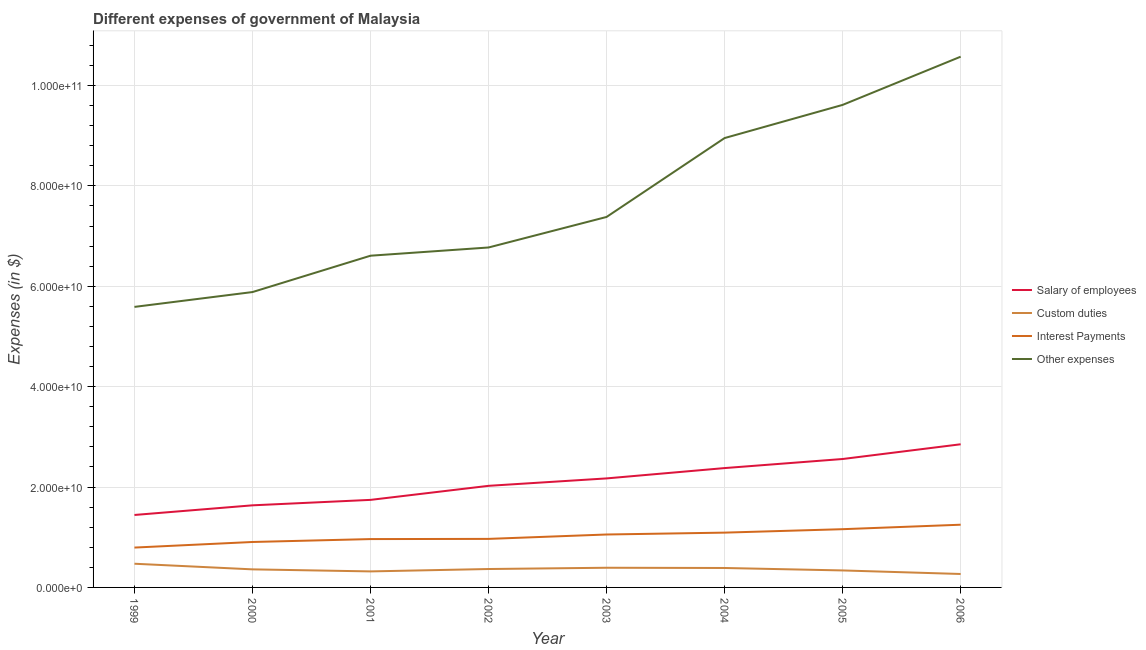How many different coloured lines are there?
Provide a succinct answer. 4. Does the line corresponding to amount spent on interest payments intersect with the line corresponding to amount spent on other expenses?
Provide a succinct answer. No. Is the number of lines equal to the number of legend labels?
Your response must be concise. Yes. What is the amount spent on salary of employees in 2003?
Give a very brief answer. 2.17e+1. Across all years, what is the maximum amount spent on custom duties?
Ensure brevity in your answer.  4.72e+09. Across all years, what is the minimum amount spent on interest payments?
Keep it short and to the point. 7.94e+09. In which year was the amount spent on salary of employees maximum?
Offer a terse response. 2006. In which year was the amount spent on other expenses minimum?
Ensure brevity in your answer.  1999. What is the total amount spent on custom duties in the graph?
Your answer should be compact. 2.90e+1. What is the difference between the amount spent on interest payments in 2001 and that in 2005?
Make the answer very short. -1.97e+09. What is the difference between the amount spent on other expenses in 2000 and the amount spent on custom duties in 2006?
Offer a terse response. 5.62e+1. What is the average amount spent on interest payments per year?
Ensure brevity in your answer.  1.02e+1. In the year 2005, what is the difference between the amount spent on other expenses and amount spent on custom duties?
Make the answer very short. 9.28e+1. What is the ratio of the amount spent on salary of employees in 2005 to that in 2006?
Give a very brief answer. 0.9. Is the amount spent on interest payments in 1999 less than that in 2006?
Offer a very short reply. Yes. What is the difference between the highest and the second highest amount spent on custom duties?
Provide a short and direct response. 8.01e+08. What is the difference between the highest and the lowest amount spent on custom duties?
Make the answer very short. 2.04e+09. Is it the case that in every year, the sum of the amount spent on other expenses and amount spent on interest payments is greater than the sum of amount spent on custom duties and amount spent on salary of employees?
Make the answer very short. No. Does the amount spent on salary of employees monotonically increase over the years?
Your response must be concise. Yes. Is the amount spent on custom duties strictly greater than the amount spent on other expenses over the years?
Give a very brief answer. No. Is the amount spent on interest payments strictly less than the amount spent on salary of employees over the years?
Make the answer very short. Yes. How many lines are there?
Your response must be concise. 4. How many years are there in the graph?
Ensure brevity in your answer.  8. What is the difference between two consecutive major ticks on the Y-axis?
Ensure brevity in your answer.  2.00e+1. Are the values on the major ticks of Y-axis written in scientific E-notation?
Ensure brevity in your answer.  Yes. Does the graph contain any zero values?
Make the answer very short. No. Where does the legend appear in the graph?
Your response must be concise. Center right. What is the title of the graph?
Your answer should be very brief. Different expenses of government of Malaysia. What is the label or title of the Y-axis?
Provide a succinct answer. Expenses (in $). What is the Expenses (in $) in Salary of employees in 1999?
Provide a short and direct response. 1.44e+1. What is the Expenses (in $) in Custom duties in 1999?
Give a very brief answer. 4.72e+09. What is the Expenses (in $) of Interest Payments in 1999?
Provide a short and direct response. 7.94e+09. What is the Expenses (in $) of Other expenses in 1999?
Your answer should be compact. 5.59e+1. What is the Expenses (in $) of Salary of employees in 2000?
Keep it short and to the point. 1.64e+1. What is the Expenses (in $) of Custom duties in 2000?
Your answer should be very brief. 3.60e+09. What is the Expenses (in $) of Interest Payments in 2000?
Give a very brief answer. 9.06e+09. What is the Expenses (in $) of Other expenses in 2000?
Provide a short and direct response. 5.88e+1. What is the Expenses (in $) in Salary of employees in 2001?
Give a very brief answer. 1.74e+1. What is the Expenses (in $) in Custom duties in 2001?
Your answer should be compact. 3.19e+09. What is the Expenses (in $) in Interest Payments in 2001?
Keep it short and to the point. 9.63e+09. What is the Expenses (in $) of Other expenses in 2001?
Your answer should be very brief. 6.61e+1. What is the Expenses (in $) of Salary of employees in 2002?
Your answer should be compact. 2.02e+1. What is the Expenses (in $) in Custom duties in 2002?
Give a very brief answer. 3.67e+09. What is the Expenses (in $) of Interest Payments in 2002?
Provide a short and direct response. 9.67e+09. What is the Expenses (in $) of Other expenses in 2002?
Your answer should be very brief. 6.77e+1. What is the Expenses (in $) of Salary of employees in 2003?
Ensure brevity in your answer.  2.17e+1. What is the Expenses (in $) of Custom duties in 2003?
Make the answer very short. 3.92e+09. What is the Expenses (in $) in Interest Payments in 2003?
Offer a terse response. 1.05e+1. What is the Expenses (in $) in Other expenses in 2003?
Ensure brevity in your answer.  7.38e+1. What is the Expenses (in $) in Salary of employees in 2004?
Offer a terse response. 2.38e+1. What is the Expenses (in $) of Custom duties in 2004?
Provide a succinct answer. 3.87e+09. What is the Expenses (in $) of Interest Payments in 2004?
Make the answer very short. 1.09e+1. What is the Expenses (in $) of Other expenses in 2004?
Keep it short and to the point. 8.95e+1. What is the Expenses (in $) of Salary of employees in 2005?
Your response must be concise. 2.56e+1. What is the Expenses (in $) in Custom duties in 2005?
Offer a very short reply. 3.38e+09. What is the Expenses (in $) in Interest Payments in 2005?
Offer a very short reply. 1.16e+1. What is the Expenses (in $) of Other expenses in 2005?
Offer a very short reply. 9.61e+1. What is the Expenses (in $) of Salary of employees in 2006?
Your answer should be compact. 2.85e+1. What is the Expenses (in $) of Custom duties in 2006?
Offer a very short reply. 2.68e+09. What is the Expenses (in $) in Interest Payments in 2006?
Offer a very short reply. 1.25e+1. What is the Expenses (in $) of Other expenses in 2006?
Provide a short and direct response. 1.06e+11. Across all years, what is the maximum Expenses (in $) in Salary of employees?
Your answer should be very brief. 2.85e+1. Across all years, what is the maximum Expenses (in $) of Custom duties?
Make the answer very short. 4.72e+09. Across all years, what is the maximum Expenses (in $) of Interest Payments?
Ensure brevity in your answer.  1.25e+1. Across all years, what is the maximum Expenses (in $) of Other expenses?
Provide a succinct answer. 1.06e+11. Across all years, what is the minimum Expenses (in $) of Salary of employees?
Make the answer very short. 1.44e+1. Across all years, what is the minimum Expenses (in $) in Custom duties?
Ensure brevity in your answer.  2.68e+09. Across all years, what is the minimum Expenses (in $) of Interest Payments?
Your answer should be very brief. 7.94e+09. Across all years, what is the minimum Expenses (in $) in Other expenses?
Your response must be concise. 5.59e+1. What is the total Expenses (in $) of Salary of employees in the graph?
Give a very brief answer. 1.68e+11. What is the total Expenses (in $) of Custom duties in the graph?
Ensure brevity in your answer.  2.90e+1. What is the total Expenses (in $) in Interest Payments in the graph?
Your answer should be very brief. 8.19e+1. What is the total Expenses (in $) in Other expenses in the graph?
Give a very brief answer. 6.14e+11. What is the difference between the Expenses (in $) in Salary of employees in 1999 and that in 2000?
Ensure brevity in your answer.  -1.92e+09. What is the difference between the Expenses (in $) of Custom duties in 1999 and that in 2000?
Make the answer very short. 1.12e+09. What is the difference between the Expenses (in $) of Interest Payments in 1999 and that in 2000?
Your response must be concise. -1.11e+09. What is the difference between the Expenses (in $) in Other expenses in 1999 and that in 2000?
Your answer should be very brief. -2.96e+09. What is the difference between the Expenses (in $) in Salary of employees in 1999 and that in 2001?
Your answer should be very brief. -3.01e+09. What is the difference between the Expenses (in $) in Custom duties in 1999 and that in 2001?
Your response must be concise. 1.53e+09. What is the difference between the Expenses (in $) of Interest Payments in 1999 and that in 2001?
Give a very brief answer. -1.69e+09. What is the difference between the Expenses (in $) of Other expenses in 1999 and that in 2001?
Give a very brief answer. -1.02e+1. What is the difference between the Expenses (in $) of Salary of employees in 1999 and that in 2002?
Offer a very short reply. -5.81e+09. What is the difference between the Expenses (in $) of Custom duties in 1999 and that in 2002?
Provide a succinct answer. 1.05e+09. What is the difference between the Expenses (in $) of Interest Payments in 1999 and that in 2002?
Offer a terse response. -1.73e+09. What is the difference between the Expenses (in $) in Other expenses in 1999 and that in 2002?
Make the answer very short. -1.18e+1. What is the difference between the Expenses (in $) in Salary of employees in 1999 and that in 2003?
Ensure brevity in your answer.  -7.28e+09. What is the difference between the Expenses (in $) in Custom duties in 1999 and that in 2003?
Offer a very short reply. 8.01e+08. What is the difference between the Expenses (in $) in Interest Payments in 1999 and that in 2003?
Your answer should be very brief. -2.60e+09. What is the difference between the Expenses (in $) of Other expenses in 1999 and that in 2003?
Your response must be concise. -1.79e+1. What is the difference between the Expenses (in $) of Salary of employees in 1999 and that in 2004?
Keep it short and to the point. -9.34e+09. What is the difference between the Expenses (in $) in Custom duties in 1999 and that in 2004?
Ensure brevity in your answer.  8.46e+08. What is the difference between the Expenses (in $) of Interest Payments in 1999 and that in 2004?
Offer a terse response. -2.98e+09. What is the difference between the Expenses (in $) in Other expenses in 1999 and that in 2004?
Your answer should be very brief. -3.36e+1. What is the difference between the Expenses (in $) in Salary of employees in 1999 and that in 2005?
Your response must be concise. -1.12e+1. What is the difference between the Expenses (in $) of Custom duties in 1999 and that in 2005?
Provide a short and direct response. 1.34e+09. What is the difference between the Expenses (in $) in Interest Payments in 1999 and that in 2005?
Make the answer very short. -3.66e+09. What is the difference between the Expenses (in $) in Other expenses in 1999 and that in 2005?
Provide a short and direct response. -4.02e+1. What is the difference between the Expenses (in $) in Salary of employees in 1999 and that in 2006?
Your answer should be very brief. -1.41e+1. What is the difference between the Expenses (in $) of Custom duties in 1999 and that in 2006?
Your answer should be compact. 2.04e+09. What is the difference between the Expenses (in $) in Interest Payments in 1999 and that in 2006?
Your answer should be compact. -4.55e+09. What is the difference between the Expenses (in $) of Other expenses in 1999 and that in 2006?
Offer a terse response. -4.99e+1. What is the difference between the Expenses (in $) in Salary of employees in 2000 and that in 2001?
Offer a terse response. -1.09e+09. What is the difference between the Expenses (in $) of Custom duties in 2000 and that in 2001?
Your answer should be very brief. 4.06e+08. What is the difference between the Expenses (in $) of Interest Payments in 2000 and that in 2001?
Your response must be concise. -5.79e+08. What is the difference between the Expenses (in $) in Other expenses in 2000 and that in 2001?
Provide a succinct answer. -7.24e+09. What is the difference between the Expenses (in $) of Salary of employees in 2000 and that in 2002?
Give a very brief answer. -3.88e+09. What is the difference between the Expenses (in $) of Custom duties in 2000 and that in 2002?
Offer a terse response. -6.89e+07. What is the difference between the Expenses (in $) in Interest Payments in 2000 and that in 2002?
Provide a succinct answer. -6.14e+08. What is the difference between the Expenses (in $) of Other expenses in 2000 and that in 2002?
Your answer should be very brief. -8.88e+09. What is the difference between the Expenses (in $) in Salary of employees in 2000 and that in 2003?
Offer a terse response. -5.36e+09. What is the difference between the Expenses (in $) of Custom duties in 2000 and that in 2003?
Make the answer very short. -3.20e+08. What is the difference between the Expenses (in $) in Interest Payments in 2000 and that in 2003?
Provide a succinct answer. -1.49e+09. What is the difference between the Expenses (in $) of Other expenses in 2000 and that in 2003?
Your response must be concise. -1.50e+1. What is the difference between the Expenses (in $) in Salary of employees in 2000 and that in 2004?
Give a very brief answer. -7.42e+09. What is the difference between the Expenses (in $) of Custom duties in 2000 and that in 2004?
Your answer should be very brief. -2.75e+08. What is the difference between the Expenses (in $) of Interest Payments in 2000 and that in 2004?
Provide a short and direct response. -1.86e+09. What is the difference between the Expenses (in $) of Other expenses in 2000 and that in 2004?
Keep it short and to the point. -3.07e+1. What is the difference between the Expenses (in $) of Salary of employees in 2000 and that in 2005?
Ensure brevity in your answer.  -9.23e+09. What is the difference between the Expenses (in $) in Custom duties in 2000 and that in 2005?
Provide a succinct answer. 2.14e+08. What is the difference between the Expenses (in $) in Interest Payments in 2000 and that in 2005?
Offer a very short reply. -2.55e+09. What is the difference between the Expenses (in $) in Other expenses in 2000 and that in 2005?
Your answer should be very brief. -3.73e+1. What is the difference between the Expenses (in $) in Salary of employees in 2000 and that in 2006?
Make the answer very short. -1.22e+1. What is the difference between the Expenses (in $) in Custom duties in 2000 and that in 2006?
Your answer should be compact. 9.20e+08. What is the difference between the Expenses (in $) in Interest Payments in 2000 and that in 2006?
Provide a short and direct response. -3.44e+09. What is the difference between the Expenses (in $) of Other expenses in 2000 and that in 2006?
Provide a succinct answer. -4.69e+1. What is the difference between the Expenses (in $) of Salary of employees in 2001 and that in 2002?
Keep it short and to the point. -2.80e+09. What is the difference between the Expenses (in $) of Custom duties in 2001 and that in 2002?
Your response must be concise. -4.75e+08. What is the difference between the Expenses (in $) in Interest Payments in 2001 and that in 2002?
Offer a very short reply. -3.50e+07. What is the difference between the Expenses (in $) of Other expenses in 2001 and that in 2002?
Keep it short and to the point. -1.64e+09. What is the difference between the Expenses (in $) in Salary of employees in 2001 and that in 2003?
Your answer should be very brief. -4.28e+09. What is the difference between the Expenses (in $) in Custom duties in 2001 and that in 2003?
Your answer should be compact. -7.26e+08. What is the difference between the Expenses (in $) of Interest Payments in 2001 and that in 2003?
Ensure brevity in your answer.  -9.12e+08. What is the difference between the Expenses (in $) in Other expenses in 2001 and that in 2003?
Offer a very short reply. -7.72e+09. What is the difference between the Expenses (in $) in Salary of employees in 2001 and that in 2004?
Keep it short and to the point. -6.34e+09. What is the difference between the Expenses (in $) in Custom duties in 2001 and that in 2004?
Keep it short and to the point. -6.81e+08. What is the difference between the Expenses (in $) of Interest Payments in 2001 and that in 2004?
Provide a short and direct response. -1.28e+09. What is the difference between the Expenses (in $) of Other expenses in 2001 and that in 2004?
Make the answer very short. -2.34e+1. What is the difference between the Expenses (in $) in Salary of employees in 2001 and that in 2005?
Keep it short and to the point. -8.14e+09. What is the difference between the Expenses (in $) in Custom duties in 2001 and that in 2005?
Keep it short and to the point. -1.92e+08. What is the difference between the Expenses (in $) in Interest Payments in 2001 and that in 2005?
Keep it short and to the point. -1.97e+09. What is the difference between the Expenses (in $) in Other expenses in 2001 and that in 2005?
Your answer should be compact. -3.00e+1. What is the difference between the Expenses (in $) of Salary of employees in 2001 and that in 2006?
Offer a very short reply. -1.11e+1. What is the difference between the Expenses (in $) of Custom duties in 2001 and that in 2006?
Give a very brief answer. 5.14e+08. What is the difference between the Expenses (in $) in Interest Payments in 2001 and that in 2006?
Provide a succinct answer. -2.86e+09. What is the difference between the Expenses (in $) in Other expenses in 2001 and that in 2006?
Your answer should be very brief. -3.97e+1. What is the difference between the Expenses (in $) of Salary of employees in 2002 and that in 2003?
Your answer should be very brief. -1.48e+09. What is the difference between the Expenses (in $) of Custom duties in 2002 and that in 2003?
Your answer should be very brief. -2.51e+08. What is the difference between the Expenses (in $) in Interest Payments in 2002 and that in 2003?
Provide a succinct answer. -8.77e+08. What is the difference between the Expenses (in $) of Other expenses in 2002 and that in 2003?
Provide a short and direct response. -6.08e+09. What is the difference between the Expenses (in $) in Salary of employees in 2002 and that in 2004?
Your answer should be very brief. -3.54e+09. What is the difference between the Expenses (in $) in Custom duties in 2002 and that in 2004?
Your answer should be very brief. -2.06e+08. What is the difference between the Expenses (in $) in Interest Payments in 2002 and that in 2004?
Keep it short and to the point. -1.25e+09. What is the difference between the Expenses (in $) in Other expenses in 2002 and that in 2004?
Ensure brevity in your answer.  -2.18e+1. What is the difference between the Expenses (in $) in Salary of employees in 2002 and that in 2005?
Make the answer very short. -5.34e+09. What is the difference between the Expenses (in $) in Custom duties in 2002 and that in 2005?
Provide a short and direct response. 2.83e+08. What is the difference between the Expenses (in $) of Interest Payments in 2002 and that in 2005?
Keep it short and to the point. -1.94e+09. What is the difference between the Expenses (in $) in Other expenses in 2002 and that in 2005?
Ensure brevity in your answer.  -2.84e+1. What is the difference between the Expenses (in $) in Salary of employees in 2002 and that in 2006?
Provide a succinct answer. -8.28e+09. What is the difference between the Expenses (in $) of Custom duties in 2002 and that in 2006?
Provide a short and direct response. 9.89e+08. What is the difference between the Expenses (in $) in Interest Payments in 2002 and that in 2006?
Provide a short and direct response. -2.83e+09. What is the difference between the Expenses (in $) of Other expenses in 2002 and that in 2006?
Your answer should be very brief. -3.80e+1. What is the difference between the Expenses (in $) in Salary of employees in 2003 and that in 2004?
Provide a short and direct response. -2.06e+09. What is the difference between the Expenses (in $) in Custom duties in 2003 and that in 2004?
Provide a short and direct response. 4.50e+07. What is the difference between the Expenses (in $) in Interest Payments in 2003 and that in 2004?
Ensure brevity in your answer.  -3.73e+08. What is the difference between the Expenses (in $) of Other expenses in 2003 and that in 2004?
Your answer should be compact. -1.57e+1. What is the difference between the Expenses (in $) in Salary of employees in 2003 and that in 2005?
Ensure brevity in your answer.  -3.87e+09. What is the difference between the Expenses (in $) of Custom duties in 2003 and that in 2005?
Provide a succinct answer. 5.34e+08. What is the difference between the Expenses (in $) in Interest Payments in 2003 and that in 2005?
Your response must be concise. -1.06e+09. What is the difference between the Expenses (in $) in Other expenses in 2003 and that in 2005?
Offer a terse response. -2.23e+1. What is the difference between the Expenses (in $) in Salary of employees in 2003 and that in 2006?
Offer a terse response. -6.80e+09. What is the difference between the Expenses (in $) of Custom duties in 2003 and that in 2006?
Provide a succinct answer. 1.24e+09. What is the difference between the Expenses (in $) in Interest Payments in 2003 and that in 2006?
Ensure brevity in your answer.  -1.95e+09. What is the difference between the Expenses (in $) in Other expenses in 2003 and that in 2006?
Give a very brief answer. -3.19e+1. What is the difference between the Expenses (in $) of Salary of employees in 2004 and that in 2005?
Your answer should be very brief. -1.81e+09. What is the difference between the Expenses (in $) in Custom duties in 2004 and that in 2005?
Your answer should be very brief. 4.89e+08. What is the difference between the Expenses (in $) of Interest Payments in 2004 and that in 2005?
Offer a terse response. -6.85e+08. What is the difference between the Expenses (in $) in Other expenses in 2004 and that in 2005?
Offer a very short reply. -6.61e+09. What is the difference between the Expenses (in $) of Salary of employees in 2004 and that in 2006?
Offer a very short reply. -4.74e+09. What is the difference between the Expenses (in $) in Custom duties in 2004 and that in 2006?
Offer a terse response. 1.20e+09. What is the difference between the Expenses (in $) of Interest Payments in 2004 and that in 2006?
Give a very brief answer. -1.58e+09. What is the difference between the Expenses (in $) of Other expenses in 2004 and that in 2006?
Offer a terse response. -1.62e+1. What is the difference between the Expenses (in $) of Salary of employees in 2005 and that in 2006?
Keep it short and to the point. -2.93e+09. What is the difference between the Expenses (in $) in Custom duties in 2005 and that in 2006?
Give a very brief answer. 7.06e+08. What is the difference between the Expenses (in $) in Interest Payments in 2005 and that in 2006?
Your answer should be compact. -8.91e+08. What is the difference between the Expenses (in $) in Other expenses in 2005 and that in 2006?
Your answer should be very brief. -9.60e+09. What is the difference between the Expenses (in $) in Salary of employees in 1999 and the Expenses (in $) in Custom duties in 2000?
Ensure brevity in your answer.  1.08e+1. What is the difference between the Expenses (in $) in Salary of employees in 1999 and the Expenses (in $) in Interest Payments in 2000?
Make the answer very short. 5.38e+09. What is the difference between the Expenses (in $) in Salary of employees in 1999 and the Expenses (in $) in Other expenses in 2000?
Ensure brevity in your answer.  -4.44e+1. What is the difference between the Expenses (in $) in Custom duties in 1999 and the Expenses (in $) in Interest Payments in 2000?
Offer a terse response. -4.33e+09. What is the difference between the Expenses (in $) in Custom duties in 1999 and the Expenses (in $) in Other expenses in 2000?
Offer a very short reply. -5.41e+1. What is the difference between the Expenses (in $) of Interest Payments in 1999 and the Expenses (in $) of Other expenses in 2000?
Offer a terse response. -5.09e+1. What is the difference between the Expenses (in $) of Salary of employees in 1999 and the Expenses (in $) of Custom duties in 2001?
Give a very brief answer. 1.12e+1. What is the difference between the Expenses (in $) of Salary of employees in 1999 and the Expenses (in $) of Interest Payments in 2001?
Make the answer very short. 4.80e+09. What is the difference between the Expenses (in $) in Salary of employees in 1999 and the Expenses (in $) in Other expenses in 2001?
Ensure brevity in your answer.  -5.17e+1. What is the difference between the Expenses (in $) in Custom duties in 1999 and the Expenses (in $) in Interest Payments in 2001?
Give a very brief answer. -4.91e+09. What is the difference between the Expenses (in $) of Custom duties in 1999 and the Expenses (in $) of Other expenses in 2001?
Make the answer very short. -6.14e+1. What is the difference between the Expenses (in $) of Interest Payments in 1999 and the Expenses (in $) of Other expenses in 2001?
Provide a short and direct response. -5.82e+1. What is the difference between the Expenses (in $) in Salary of employees in 1999 and the Expenses (in $) in Custom duties in 2002?
Make the answer very short. 1.08e+1. What is the difference between the Expenses (in $) of Salary of employees in 1999 and the Expenses (in $) of Interest Payments in 2002?
Provide a succinct answer. 4.77e+09. What is the difference between the Expenses (in $) in Salary of employees in 1999 and the Expenses (in $) in Other expenses in 2002?
Offer a terse response. -5.33e+1. What is the difference between the Expenses (in $) of Custom duties in 1999 and the Expenses (in $) of Interest Payments in 2002?
Offer a very short reply. -4.95e+09. What is the difference between the Expenses (in $) in Custom duties in 1999 and the Expenses (in $) in Other expenses in 2002?
Ensure brevity in your answer.  -6.30e+1. What is the difference between the Expenses (in $) in Interest Payments in 1999 and the Expenses (in $) in Other expenses in 2002?
Ensure brevity in your answer.  -5.98e+1. What is the difference between the Expenses (in $) of Salary of employees in 1999 and the Expenses (in $) of Custom duties in 2003?
Your answer should be very brief. 1.05e+1. What is the difference between the Expenses (in $) of Salary of employees in 1999 and the Expenses (in $) of Interest Payments in 2003?
Provide a short and direct response. 3.89e+09. What is the difference between the Expenses (in $) of Salary of employees in 1999 and the Expenses (in $) of Other expenses in 2003?
Offer a very short reply. -5.94e+1. What is the difference between the Expenses (in $) of Custom duties in 1999 and the Expenses (in $) of Interest Payments in 2003?
Make the answer very short. -5.83e+09. What is the difference between the Expenses (in $) in Custom duties in 1999 and the Expenses (in $) in Other expenses in 2003?
Give a very brief answer. -6.91e+1. What is the difference between the Expenses (in $) of Interest Payments in 1999 and the Expenses (in $) of Other expenses in 2003?
Keep it short and to the point. -6.59e+1. What is the difference between the Expenses (in $) of Salary of employees in 1999 and the Expenses (in $) of Custom duties in 2004?
Your answer should be compact. 1.06e+1. What is the difference between the Expenses (in $) in Salary of employees in 1999 and the Expenses (in $) in Interest Payments in 2004?
Offer a very short reply. 3.52e+09. What is the difference between the Expenses (in $) of Salary of employees in 1999 and the Expenses (in $) of Other expenses in 2004?
Your response must be concise. -7.51e+1. What is the difference between the Expenses (in $) in Custom duties in 1999 and the Expenses (in $) in Interest Payments in 2004?
Your answer should be very brief. -6.20e+09. What is the difference between the Expenses (in $) in Custom duties in 1999 and the Expenses (in $) in Other expenses in 2004?
Your response must be concise. -8.48e+1. What is the difference between the Expenses (in $) in Interest Payments in 1999 and the Expenses (in $) in Other expenses in 2004?
Provide a short and direct response. -8.16e+1. What is the difference between the Expenses (in $) in Salary of employees in 1999 and the Expenses (in $) in Custom duties in 2005?
Offer a terse response. 1.11e+1. What is the difference between the Expenses (in $) of Salary of employees in 1999 and the Expenses (in $) of Interest Payments in 2005?
Offer a very short reply. 2.83e+09. What is the difference between the Expenses (in $) of Salary of employees in 1999 and the Expenses (in $) of Other expenses in 2005?
Give a very brief answer. -8.17e+1. What is the difference between the Expenses (in $) in Custom duties in 1999 and the Expenses (in $) in Interest Payments in 2005?
Your answer should be very brief. -6.88e+09. What is the difference between the Expenses (in $) of Custom duties in 1999 and the Expenses (in $) of Other expenses in 2005?
Provide a succinct answer. -9.14e+1. What is the difference between the Expenses (in $) of Interest Payments in 1999 and the Expenses (in $) of Other expenses in 2005?
Provide a succinct answer. -8.82e+1. What is the difference between the Expenses (in $) in Salary of employees in 1999 and the Expenses (in $) in Custom duties in 2006?
Provide a short and direct response. 1.18e+1. What is the difference between the Expenses (in $) in Salary of employees in 1999 and the Expenses (in $) in Interest Payments in 2006?
Keep it short and to the point. 1.94e+09. What is the difference between the Expenses (in $) in Salary of employees in 1999 and the Expenses (in $) in Other expenses in 2006?
Your answer should be compact. -9.13e+1. What is the difference between the Expenses (in $) in Custom duties in 1999 and the Expenses (in $) in Interest Payments in 2006?
Your answer should be compact. -7.78e+09. What is the difference between the Expenses (in $) in Custom duties in 1999 and the Expenses (in $) in Other expenses in 2006?
Make the answer very short. -1.01e+11. What is the difference between the Expenses (in $) in Interest Payments in 1999 and the Expenses (in $) in Other expenses in 2006?
Ensure brevity in your answer.  -9.78e+1. What is the difference between the Expenses (in $) of Salary of employees in 2000 and the Expenses (in $) of Custom duties in 2001?
Your answer should be compact. 1.32e+1. What is the difference between the Expenses (in $) in Salary of employees in 2000 and the Expenses (in $) in Interest Payments in 2001?
Provide a succinct answer. 6.72e+09. What is the difference between the Expenses (in $) of Salary of employees in 2000 and the Expenses (in $) of Other expenses in 2001?
Provide a succinct answer. -4.97e+1. What is the difference between the Expenses (in $) in Custom duties in 2000 and the Expenses (in $) in Interest Payments in 2001?
Offer a terse response. -6.03e+09. What is the difference between the Expenses (in $) in Custom duties in 2000 and the Expenses (in $) in Other expenses in 2001?
Your answer should be very brief. -6.25e+1. What is the difference between the Expenses (in $) of Interest Payments in 2000 and the Expenses (in $) of Other expenses in 2001?
Keep it short and to the point. -5.70e+1. What is the difference between the Expenses (in $) of Salary of employees in 2000 and the Expenses (in $) of Custom duties in 2002?
Make the answer very short. 1.27e+1. What is the difference between the Expenses (in $) of Salary of employees in 2000 and the Expenses (in $) of Interest Payments in 2002?
Offer a terse response. 6.69e+09. What is the difference between the Expenses (in $) of Salary of employees in 2000 and the Expenses (in $) of Other expenses in 2002?
Make the answer very short. -5.14e+1. What is the difference between the Expenses (in $) of Custom duties in 2000 and the Expenses (in $) of Interest Payments in 2002?
Offer a terse response. -6.07e+09. What is the difference between the Expenses (in $) in Custom duties in 2000 and the Expenses (in $) in Other expenses in 2002?
Provide a short and direct response. -6.41e+1. What is the difference between the Expenses (in $) of Interest Payments in 2000 and the Expenses (in $) of Other expenses in 2002?
Offer a terse response. -5.87e+1. What is the difference between the Expenses (in $) of Salary of employees in 2000 and the Expenses (in $) of Custom duties in 2003?
Offer a terse response. 1.24e+1. What is the difference between the Expenses (in $) in Salary of employees in 2000 and the Expenses (in $) in Interest Payments in 2003?
Provide a succinct answer. 5.81e+09. What is the difference between the Expenses (in $) of Salary of employees in 2000 and the Expenses (in $) of Other expenses in 2003?
Keep it short and to the point. -5.75e+1. What is the difference between the Expenses (in $) in Custom duties in 2000 and the Expenses (in $) in Interest Payments in 2003?
Your answer should be very brief. -6.95e+09. What is the difference between the Expenses (in $) of Custom duties in 2000 and the Expenses (in $) of Other expenses in 2003?
Your response must be concise. -7.02e+1. What is the difference between the Expenses (in $) of Interest Payments in 2000 and the Expenses (in $) of Other expenses in 2003?
Keep it short and to the point. -6.48e+1. What is the difference between the Expenses (in $) in Salary of employees in 2000 and the Expenses (in $) in Custom duties in 2004?
Your answer should be compact. 1.25e+1. What is the difference between the Expenses (in $) in Salary of employees in 2000 and the Expenses (in $) in Interest Payments in 2004?
Keep it short and to the point. 5.44e+09. What is the difference between the Expenses (in $) in Salary of employees in 2000 and the Expenses (in $) in Other expenses in 2004?
Offer a terse response. -7.32e+1. What is the difference between the Expenses (in $) in Custom duties in 2000 and the Expenses (in $) in Interest Payments in 2004?
Offer a very short reply. -7.32e+09. What is the difference between the Expenses (in $) of Custom duties in 2000 and the Expenses (in $) of Other expenses in 2004?
Your answer should be compact. -8.59e+1. What is the difference between the Expenses (in $) of Interest Payments in 2000 and the Expenses (in $) of Other expenses in 2004?
Keep it short and to the point. -8.05e+1. What is the difference between the Expenses (in $) in Salary of employees in 2000 and the Expenses (in $) in Custom duties in 2005?
Your answer should be compact. 1.30e+1. What is the difference between the Expenses (in $) of Salary of employees in 2000 and the Expenses (in $) of Interest Payments in 2005?
Provide a short and direct response. 4.75e+09. What is the difference between the Expenses (in $) in Salary of employees in 2000 and the Expenses (in $) in Other expenses in 2005?
Offer a terse response. -7.98e+1. What is the difference between the Expenses (in $) of Custom duties in 2000 and the Expenses (in $) of Interest Payments in 2005?
Ensure brevity in your answer.  -8.00e+09. What is the difference between the Expenses (in $) in Custom duties in 2000 and the Expenses (in $) in Other expenses in 2005?
Offer a terse response. -9.25e+1. What is the difference between the Expenses (in $) of Interest Payments in 2000 and the Expenses (in $) of Other expenses in 2005?
Your response must be concise. -8.71e+1. What is the difference between the Expenses (in $) in Salary of employees in 2000 and the Expenses (in $) in Custom duties in 2006?
Offer a very short reply. 1.37e+1. What is the difference between the Expenses (in $) of Salary of employees in 2000 and the Expenses (in $) of Interest Payments in 2006?
Provide a short and direct response. 3.86e+09. What is the difference between the Expenses (in $) of Salary of employees in 2000 and the Expenses (in $) of Other expenses in 2006?
Give a very brief answer. -8.94e+1. What is the difference between the Expenses (in $) in Custom duties in 2000 and the Expenses (in $) in Interest Payments in 2006?
Your answer should be compact. -8.90e+09. What is the difference between the Expenses (in $) in Custom duties in 2000 and the Expenses (in $) in Other expenses in 2006?
Keep it short and to the point. -1.02e+11. What is the difference between the Expenses (in $) of Interest Payments in 2000 and the Expenses (in $) of Other expenses in 2006?
Offer a terse response. -9.67e+1. What is the difference between the Expenses (in $) of Salary of employees in 2001 and the Expenses (in $) of Custom duties in 2002?
Your answer should be very brief. 1.38e+1. What is the difference between the Expenses (in $) in Salary of employees in 2001 and the Expenses (in $) in Interest Payments in 2002?
Make the answer very short. 7.77e+09. What is the difference between the Expenses (in $) of Salary of employees in 2001 and the Expenses (in $) of Other expenses in 2002?
Give a very brief answer. -5.03e+1. What is the difference between the Expenses (in $) in Custom duties in 2001 and the Expenses (in $) in Interest Payments in 2002?
Provide a succinct answer. -6.48e+09. What is the difference between the Expenses (in $) of Custom duties in 2001 and the Expenses (in $) of Other expenses in 2002?
Provide a succinct answer. -6.45e+1. What is the difference between the Expenses (in $) of Interest Payments in 2001 and the Expenses (in $) of Other expenses in 2002?
Give a very brief answer. -5.81e+1. What is the difference between the Expenses (in $) in Salary of employees in 2001 and the Expenses (in $) in Custom duties in 2003?
Your answer should be compact. 1.35e+1. What is the difference between the Expenses (in $) of Salary of employees in 2001 and the Expenses (in $) of Interest Payments in 2003?
Your response must be concise. 6.90e+09. What is the difference between the Expenses (in $) of Salary of employees in 2001 and the Expenses (in $) of Other expenses in 2003?
Your answer should be compact. -5.64e+1. What is the difference between the Expenses (in $) in Custom duties in 2001 and the Expenses (in $) in Interest Payments in 2003?
Make the answer very short. -7.35e+09. What is the difference between the Expenses (in $) of Custom duties in 2001 and the Expenses (in $) of Other expenses in 2003?
Keep it short and to the point. -7.06e+1. What is the difference between the Expenses (in $) in Interest Payments in 2001 and the Expenses (in $) in Other expenses in 2003?
Your answer should be very brief. -6.42e+1. What is the difference between the Expenses (in $) of Salary of employees in 2001 and the Expenses (in $) of Custom duties in 2004?
Your answer should be very brief. 1.36e+1. What is the difference between the Expenses (in $) in Salary of employees in 2001 and the Expenses (in $) in Interest Payments in 2004?
Your answer should be compact. 6.52e+09. What is the difference between the Expenses (in $) in Salary of employees in 2001 and the Expenses (in $) in Other expenses in 2004?
Your answer should be compact. -7.21e+1. What is the difference between the Expenses (in $) in Custom duties in 2001 and the Expenses (in $) in Interest Payments in 2004?
Provide a short and direct response. -7.73e+09. What is the difference between the Expenses (in $) in Custom duties in 2001 and the Expenses (in $) in Other expenses in 2004?
Ensure brevity in your answer.  -8.63e+1. What is the difference between the Expenses (in $) in Interest Payments in 2001 and the Expenses (in $) in Other expenses in 2004?
Your answer should be very brief. -7.99e+1. What is the difference between the Expenses (in $) of Salary of employees in 2001 and the Expenses (in $) of Custom duties in 2005?
Give a very brief answer. 1.41e+1. What is the difference between the Expenses (in $) of Salary of employees in 2001 and the Expenses (in $) of Interest Payments in 2005?
Give a very brief answer. 5.84e+09. What is the difference between the Expenses (in $) of Salary of employees in 2001 and the Expenses (in $) of Other expenses in 2005?
Offer a very short reply. -7.87e+1. What is the difference between the Expenses (in $) in Custom duties in 2001 and the Expenses (in $) in Interest Payments in 2005?
Keep it short and to the point. -8.41e+09. What is the difference between the Expenses (in $) of Custom duties in 2001 and the Expenses (in $) of Other expenses in 2005?
Provide a succinct answer. -9.29e+1. What is the difference between the Expenses (in $) of Interest Payments in 2001 and the Expenses (in $) of Other expenses in 2005?
Provide a succinct answer. -8.65e+1. What is the difference between the Expenses (in $) of Salary of employees in 2001 and the Expenses (in $) of Custom duties in 2006?
Offer a terse response. 1.48e+1. What is the difference between the Expenses (in $) in Salary of employees in 2001 and the Expenses (in $) in Interest Payments in 2006?
Your response must be concise. 4.95e+09. What is the difference between the Expenses (in $) of Salary of employees in 2001 and the Expenses (in $) of Other expenses in 2006?
Your answer should be compact. -8.83e+1. What is the difference between the Expenses (in $) in Custom duties in 2001 and the Expenses (in $) in Interest Payments in 2006?
Provide a short and direct response. -9.30e+09. What is the difference between the Expenses (in $) in Custom duties in 2001 and the Expenses (in $) in Other expenses in 2006?
Give a very brief answer. -1.03e+11. What is the difference between the Expenses (in $) in Interest Payments in 2001 and the Expenses (in $) in Other expenses in 2006?
Keep it short and to the point. -9.61e+1. What is the difference between the Expenses (in $) of Salary of employees in 2002 and the Expenses (in $) of Custom duties in 2003?
Offer a very short reply. 1.63e+1. What is the difference between the Expenses (in $) of Salary of employees in 2002 and the Expenses (in $) of Interest Payments in 2003?
Offer a very short reply. 9.70e+09. What is the difference between the Expenses (in $) in Salary of employees in 2002 and the Expenses (in $) in Other expenses in 2003?
Ensure brevity in your answer.  -5.36e+1. What is the difference between the Expenses (in $) of Custom duties in 2002 and the Expenses (in $) of Interest Payments in 2003?
Make the answer very short. -6.88e+09. What is the difference between the Expenses (in $) in Custom duties in 2002 and the Expenses (in $) in Other expenses in 2003?
Provide a short and direct response. -7.01e+1. What is the difference between the Expenses (in $) of Interest Payments in 2002 and the Expenses (in $) of Other expenses in 2003?
Offer a terse response. -6.41e+1. What is the difference between the Expenses (in $) in Salary of employees in 2002 and the Expenses (in $) in Custom duties in 2004?
Your response must be concise. 1.64e+1. What is the difference between the Expenses (in $) of Salary of employees in 2002 and the Expenses (in $) of Interest Payments in 2004?
Offer a terse response. 9.32e+09. What is the difference between the Expenses (in $) of Salary of employees in 2002 and the Expenses (in $) of Other expenses in 2004?
Ensure brevity in your answer.  -6.93e+1. What is the difference between the Expenses (in $) of Custom duties in 2002 and the Expenses (in $) of Interest Payments in 2004?
Keep it short and to the point. -7.25e+09. What is the difference between the Expenses (in $) in Custom duties in 2002 and the Expenses (in $) in Other expenses in 2004?
Offer a very short reply. -8.59e+1. What is the difference between the Expenses (in $) in Interest Payments in 2002 and the Expenses (in $) in Other expenses in 2004?
Offer a terse response. -7.99e+1. What is the difference between the Expenses (in $) in Salary of employees in 2002 and the Expenses (in $) in Custom duties in 2005?
Offer a terse response. 1.69e+1. What is the difference between the Expenses (in $) in Salary of employees in 2002 and the Expenses (in $) in Interest Payments in 2005?
Give a very brief answer. 8.64e+09. What is the difference between the Expenses (in $) of Salary of employees in 2002 and the Expenses (in $) of Other expenses in 2005?
Offer a terse response. -7.59e+1. What is the difference between the Expenses (in $) of Custom duties in 2002 and the Expenses (in $) of Interest Payments in 2005?
Your response must be concise. -7.94e+09. What is the difference between the Expenses (in $) of Custom duties in 2002 and the Expenses (in $) of Other expenses in 2005?
Keep it short and to the point. -9.25e+1. What is the difference between the Expenses (in $) in Interest Payments in 2002 and the Expenses (in $) in Other expenses in 2005?
Make the answer very short. -8.65e+1. What is the difference between the Expenses (in $) in Salary of employees in 2002 and the Expenses (in $) in Custom duties in 2006?
Offer a very short reply. 1.76e+1. What is the difference between the Expenses (in $) in Salary of employees in 2002 and the Expenses (in $) in Interest Payments in 2006?
Make the answer very short. 7.75e+09. What is the difference between the Expenses (in $) in Salary of employees in 2002 and the Expenses (in $) in Other expenses in 2006?
Offer a terse response. -8.55e+1. What is the difference between the Expenses (in $) of Custom duties in 2002 and the Expenses (in $) of Interest Payments in 2006?
Provide a succinct answer. -8.83e+09. What is the difference between the Expenses (in $) in Custom duties in 2002 and the Expenses (in $) in Other expenses in 2006?
Your response must be concise. -1.02e+11. What is the difference between the Expenses (in $) of Interest Payments in 2002 and the Expenses (in $) of Other expenses in 2006?
Offer a very short reply. -9.61e+1. What is the difference between the Expenses (in $) of Salary of employees in 2003 and the Expenses (in $) of Custom duties in 2004?
Give a very brief answer. 1.78e+1. What is the difference between the Expenses (in $) of Salary of employees in 2003 and the Expenses (in $) of Interest Payments in 2004?
Your response must be concise. 1.08e+1. What is the difference between the Expenses (in $) of Salary of employees in 2003 and the Expenses (in $) of Other expenses in 2004?
Your answer should be compact. -6.78e+1. What is the difference between the Expenses (in $) in Custom duties in 2003 and the Expenses (in $) in Interest Payments in 2004?
Keep it short and to the point. -7.00e+09. What is the difference between the Expenses (in $) of Custom duties in 2003 and the Expenses (in $) of Other expenses in 2004?
Give a very brief answer. -8.56e+1. What is the difference between the Expenses (in $) in Interest Payments in 2003 and the Expenses (in $) in Other expenses in 2004?
Ensure brevity in your answer.  -7.90e+1. What is the difference between the Expenses (in $) in Salary of employees in 2003 and the Expenses (in $) in Custom duties in 2005?
Give a very brief answer. 1.83e+1. What is the difference between the Expenses (in $) of Salary of employees in 2003 and the Expenses (in $) of Interest Payments in 2005?
Your answer should be very brief. 1.01e+1. What is the difference between the Expenses (in $) in Salary of employees in 2003 and the Expenses (in $) in Other expenses in 2005?
Give a very brief answer. -7.44e+1. What is the difference between the Expenses (in $) of Custom duties in 2003 and the Expenses (in $) of Interest Payments in 2005?
Offer a very short reply. -7.68e+09. What is the difference between the Expenses (in $) of Custom duties in 2003 and the Expenses (in $) of Other expenses in 2005?
Offer a terse response. -9.22e+1. What is the difference between the Expenses (in $) of Interest Payments in 2003 and the Expenses (in $) of Other expenses in 2005?
Your answer should be compact. -8.56e+1. What is the difference between the Expenses (in $) in Salary of employees in 2003 and the Expenses (in $) in Custom duties in 2006?
Provide a succinct answer. 1.90e+1. What is the difference between the Expenses (in $) of Salary of employees in 2003 and the Expenses (in $) of Interest Payments in 2006?
Keep it short and to the point. 9.23e+09. What is the difference between the Expenses (in $) in Salary of employees in 2003 and the Expenses (in $) in Other expenses in 2006?
Your answer should be very brief. -8.40e+1. What is the difference between the Expenses (in $) of Custom duties in 2003 and the Expenses (in $) of Interest Payments in 2006?
Provide a succinct answer. -8.58e+09. What is the difference between the Expenses (in $) of Custom duties in 2003 and the Expenses (in $) of Other expenses in 2006?
Ensure brevity in your answer.  -1.02e+11. What is the difference between the Expenses (in $) in Interest Payments in 2003 and the Expenses (in $) in Other expenses in 2006?
Provide a short and direct response. -9.52e+1. What is the difference between the Expenses (in $) of Salary of employees in 2004 and the Expenses (in $) of Custom duties in 2005?
Provide a succinct answer. 2.04e+1. What is the difference between the Expenses (in $) in Salary of employees in 2004 and the Expenses (in $) in Interest Payments in 2005?
Your response must be concise. 1.22e+1. What is the difference between the Expenses (in $) of Salary of employees in 2004 and the Expenses (in $) of Other expenses in 2005?
Ensure brevity in your answer.  -7.24e+1. What is the difference between the Expenses (in $) of Custom duties in 2004 and the Expenses (in $) of Interest Payments in 2005?
Provide a short and direct response. -7.73e+09. What is the difference between the Expenses (in $) of Custom duties in 2004 and the Expenses (in $) of Other expenses in 2005?
Provide a succinct answer. -9.23e+1. What is the difference between the Expenses (in $) in Interest Payments in 2004 and the Expenses (in $) in Other expenses in 2005?
Provide a succinct answer. -8.52e+1. What is the difference between the Expenses (in $) in Salary of employees in 2004 and the Expenses (in $) in Custom duties in 2006?
Offer a terse response. 2.11e+1. What is the difference between the Expenses (in $) in Salary of employees in 2004 and the Expenses (in $) in Interest Payments in 2006?
Offer a terse response. 1.13e+1. What is the difference between the Expenses (in $) in Salary of employees in 2004 and the Expenses (in $) in Other expenses in 2006?
Make the answer very short. -8.20e+1. What is the difference between the Expenses (in $) of Custom duties in 2004 and the Expenses (in $) of Interest Payments in 2006?
Your answer should be very brief. -8.62e+09. What is the difference between the Expenses (in $) of Custom duties in 2004 and the Expenses (in $) of Other expenses in 2006?
Give a very brief answer. -1.02e+11. What is the difference between the Expenses (in $) in Interest Payments in 2004 and the Expenses (in $) in Other expenses in 2006?
Your response must be concise. -9.48e+1. What is the difference between the Expenses (in $) in Salary of employees in 2005 and the Expenses (in $) in Custom duties in 2006?
Provide a short and direct response. 2.29e+1. What is the difference between the Expenses (in $) of Salary of employees in 2005 and the Expenses (in $) of Interest Payments in 2006?
Provide a succinct answer. 1.31e+1. What is the difference between the Expenses (in $) in Salary of employees in 2005 and the Expenses (in $) in Other expenses in 2006?
Provide a short and direct response. -8.02e+1. What is the difference between the Expenses (in $) in Custom duties in 2005 and the Expenses (in $) in Interest Payments in 2006?
Offer a very short reply. -9.11e+09. What is the difference between the Expenses (in $) of Custom duties in 2005 and the Expenses (in $) of Other expenses in 2006?
Give a very brief answer. -1.02e+11. What is the difference between the Expenses (in $) of Interest Payments in 2005 and the Expenses (in $) of Other expenses in 2006?
Offer a terse response. -9.41e+1. What is the average Expenses (in $) of Salary of employees per year?
Your response must be concise. 2.10e+1. What is the average Expenses (in $) of Custom duties per year?
Offer a terse response. 3.63e+09. What is the average Expenses (in $) in Interest Payments per year?
Your answer should be very brief. 1.02e+1. What is the average Expenses (in $) of Other expenses per year?
Offer a terse response. 7.67e+1. In the year 1999, what is the difference between the Expenses (in $) of Salary of employees and Expenses (in $) of Custom duties?
Offer a very short reply. 9.72e+09. In the year 1999, what is the difference between the Expenses (in $) of Salary of employees and Expenses (in $) of Interest Payments?
Your response must be concise. 6.50e+09. In the year 1999, what is the difference between the Expenses (in $) of Salary of employees and Expenses (in $) of Other expenses?
Ensure brevity in your answer.  -4.15e+1. In the year 1999, what is the difference between the Expenses (in $) of Custom duties and Expenses (in $) of Interest Payments?
Offer a terse response. -3.22e+09. In the year 1999, what is the difference between the Expenses (in $) of Custom duties and Expenses (in $) of Other expenses?
Provide a succinct answer. -5.12e+1. In the year 1999, what is the difference between the Expenses (in $) of Interest Payments and Expenses (in $) of Other expenses?
Offer a terse response. -4.80e+1. In the year 2000, what is the difference between the Expenses (in $) of Salary of employees and Expenses (in $) of Custom duties?
Your answer should be very brief. 1.28e+1. In the year 2000, what is the difference between the Expenses (in $) in Salary of employees and Expenses (in $) in Interest Payments?
Ensure brevity in your answer.  7.30e+09. In the year 2000, what is the difference between the Expenses (in $) in Salary of employees and Expenses (in $) in Other expenses?
Your response must be concise. -4.25e+1. In the year 2000, what is the difference between the Expenses (in $) in Custom duties and Expenses (in $) in Interest Payments?
Offer a terse response. -5.46e+09. In the year 2000, what is the difference between the Expenses (in $) in Custom duties and Expenses (in $) in Other expenses?
Offer a very short reply. -5.53e+1. In the year 2000, what is the difference between the Expenses (in $) in Interest Payments and Expenses (in $) in Other expenses?
Give a very brief answer. -4.98e+1. In the year 2001, what is the difference between the Expenses (in $) of Salary of employees and Expenses (in $) of Custom duties?
Your answer should be very brief. 1.42e+1. In the year 2001, what is the difference between the Expenses (in $) in Salary of employees and Expenses (in $) in Interest Payments?
Offer a very short reply. 7.81e+09. In the year 2001, what is the difference between the Expenses (in $) of Salary of employees and Expenses (in $) of Other expenses?
Make the answer very short. -4.86e+1. In the year 2001, what is the difference between the Expenses (in $) in Custom duties and Expenses (in $) in Interest Payments?
Provide a succinct answer. -6.44e+09. In the year 2001, what is the difference between the Expenses (in $) in Custom duties and Expenses (in $) in Other expenses?
Offer a terse response. -6.29e+1. In the year 2001, what is the difference between the Expenses (in $) in Interest Payments and Expenses (in $) in Other expenses?
Keep it short and to the point. -5.65e+1. In the year 2002, what is the difference between the Expenses (in $) of Salary of employees and Expenses (in $) of Custom duties?
Make the answer very short. 1.66e+1. In the year 2002, what is the difference between the Expenses (in $) in Salary of employees and Expenses (in $) in Interest Payments?
Offer a terse response. 1.06e+1. In the year 2002, what is the difference between the Expenses (in $) of Salary of employees and Expenses (in $) of Other expenses?
Give a very brief answer. -4.75e+1. In the year 2002, what is the difference between the Expenses (in $) in Custom duties and Expenses (in $) in Interest Payments?
Make the answer very short. -6.00e+09. In the year 2002, what is the difference between the Expenses (in $) of Custom duties and Expenses (in $) of Other expenses?
Keep it short and to the point. -6.41e+1. In the year 2002, what is the difference between the Expenses (in $) of Interest Payments and Expenses (in $) of Other expenses?
Your response must be concise. -5.81e+1. In the year 2003, what is the difference between the Expenses (in $) in Salary of employees and Expenses (in $) in Custom duties?
Make the answer very short. 1.78e+1. In the year 2003, what is the difference between the Expenses (in $) of Salary of employees and Expenses (in $) of Interest Payments?
Your response must be concise. 1.12e+1. In the year 2003, what is the difference between the Expenses (in $) in Salary of employees and Expenses (in $) in Other expenses?
Offer a terse response. -5.21e+1. In the year 2003, what is the difference between the Expenses (in $) of Custom duties and Expenses (in $) of Interest Payments?
Give a very brief answer. -6.63e+09. In the year 2003, what is the difference between the Expenses (in $) in Custom duties and Expenses (in $) in Other expenses?
Keep it short and to the point. -6.99e+1. In the year 2003, what is the difference between the Expenses (in $) in Interest Payments and Expenses (in $) in Other expenses?
Your answer should be very brief. -6.33e+1. In the year 2004, what is the difference between the Expenses (in $) in Salary of employees and Expenses (in $) in Custom duties?
Offer a terse response. 1.99e+1. In the year 2004, what is the difference between the Expenses (in $) in Salary of employees and Expenses (in $) in Interest Payments?
Your response must be concise. 1.29e+1. In the year 2004, what is the difference between the Expenses (in $) of Salary of employees and Expenses (in $) of Other expenses?
Ensure brevity in your answer.  -6.58e+1. In the year 2004, what is the difference between the Expenses (in $) of Custom duties and Expenses (in $) of Interest Payments?
Provide a short and direct response. -7.04e+09. In the year 2004, what is the difference between the Expenses (in $) in Custom duties and Expenses (in $) in Other expenses?
Offer a terse response. -8.57e+1. In the year 2004, what is the difference between the Expenses (in $) of Interest Payments and Expenses (in $) of Other expenses?
Offer a very short reply. -7.86e+1. In the year 2005, what is the difference between the Expenses (in $) of Salary of employees and Expenses (in $) of Custom duties?
Ensure brevity in your answer.  2.22e+1. In the year 2005, what is the difference between the Expenses (in $) in Salary of employees and Expenses (in $) in Interest Payments?
Provide a short and direct response. 1.40e+1. In the year 2005, what is the difference between the Expenses (in $) of Salary of employees and Expenses (in $) of Other expenses?
Offer a terse response. -7.06e+1. In the year 2005, what is the difference between the Expenses (in $) in Custom duties and Expenses (in $) in Interest Payments?
Offer a terse response. -8.22e+09. In the year 2005, what is the difference between the Expenses (in $) in Custom duties and Expenses (in $) in Other expenses?
Your answer should be very brief. -9.28e+1. In the year 2005, what is the difference between the Expenses (in $) in Interest Payments and Expenses (in $) in Other expenses?
Provide a short and direct response. -8.45e+1. In the year 2006, what is the difference between the Expenses (in $) in Salary of employees and Expenses (in $) in Custom duties?
Provide a short and direct response. 2.58e+1. In the year 2006, what is the difference between the Expenses (in $) in Salary of employees and Expenses (in $) in Interest Payments?
Give a very brief answer. 1.60e+1. In the year 2006, what is the difference between the Expenses (in $) of Salary of employees and Expenses (in $) of Other expenses?
Ensure brevity in your answer.  -7.72e+1. In the year 2006, what is the difference between the Expenses (in $) in Custom duties and Expenses (in $) in Interest Payments?
Your answer should be very brief. -9.82e+09. In the year 2006, what is the difference between the Expenses (in $) of Custom duties and Expenses (in $) of Other expenses?
Your answer should be compact. -1.03e+11. In the year 2006, what is the difference between the Expenses (in $) of Interest Payments and Expenses (in $) of Other expenses?
Offer a very short reply. -9.32e+1. What is the ratio of the Expenses (in $) in Salary of employees in 1999 to that in 2000?
Ensure brevity in your answer.  0.88. What is the ratio of the Expenses (in $) in Custom duties in 1999 to that in 2000?
Provide a succinct answer. 1.31. What is the ratio of the Expenses (in $) of Interest Payments in 1999 to that in 2000?
Offer a very short reply. 0.88. What is the ratio of the Expenses (in $) of Other expenses in 1999 to that in 2000?
Your answer should be compact. 0.95. What is the ratio of the Expenses (in $) of Salary of employees in 1999 to that in 2001?
Ensure brevity in your answer.  0.83. What is the ratio of the Expenses (in $) in Custom duties in 1999 to that in 2001?
Ensure brevity in your answer.  1.48. What is the ratio of the Expenses (in $) of Interest Payments in 1999 to that in 2001?
Make the answer very short. 0.82. What is the ratio of the Expenses (in $) in Other expenses in 1999 to that in 2001?
Give a very brief answer. 0.85. What is the ratio of the Expenses (in $) of Salary of employees in 1999 to that in 2002?
Your answer should be compact. 0.71. What is the ratio of the Expenses (in $) of Custom duties in 1999 to that in 2002?
Offer a very short reply. 1.29. What is the ratio of the Expenses (in $) in Interest Payments in 1999 to that in 2002?
Provide a succinct answer. 0.82. What is the ratio of the Expenses (in $) in Other expenses in 1999 to that in 2002?
Your answer should be very brief. 0.83. What is the ratio of the Expenses (in $) in Salary of employees in 1999 to that in 2003?
Offer a terse response. 0.66. What is the ratio of the Expenses (in $) of Custom duties in 1999 to that in 2003?
Your answer should be very brief. 1.2. What is the ratio of the Expenses (in $) of Interest Payments in 1999 to that in 2003?
Ensure brevity in your answer.  0.75. What is the ratio of the Expenses (in $) of Other expenses in 1999 to that in 2003?
Keep it short and to the point. 0.76. What is the ratio of the Expenses (in $) of Salary of employees in 1999 to that in 2004?
Offer a very short reply. 0.61. What is the ratio of the Expenses (in $) of Custom duties in 1999 to that in 2004?
Provide a short and direct response. 1.22. What is the ratio of the Expenses (in $) of Interest Payments in 1999 to that in 2004?
Offer a very short reply. 0.73. What is the ratio of the Expenses (in $) of Other expenses in 1999 to that in 2004?
Offer a very short reply. 0.62. What is the ratio of the Expenses (in $) of Salary of employees in 1999 to that in 2005?
Your answer should be compact. 0.56. What is the ratio of the Expenses (in $) in Custom duties in 1999 to that in 2005?
Provide a short and direct response. 1.39. What is the ratio of the Expenses (in $) in Interest Payments in 1999 to that in 2005?
Provide a short and direct response. 0.68. What is the ratio of the Expenses (in $) of Other expenses in 1999 to that in 2005?
Offer a very short reply. 0.58. What is the ratio of the Expenses (in $) of Salary of employees in 1999 to that in 2006?
Keep it short and to the point. 0.51. What is the ratio of the Expenses (in $) in Custom duties in 1999 to that in 2006?
Your response must be concise. 1.76. What is the ratio of the Expenses (in $) of Interest Payments in 1999 to that in 2006?
Ensure brevity in your answer.  0.64. What is the ratio of the Expenses (in $) in Other expenses in 1999 to that in 2006?
Provide a succinct answer. 0.53. What is the ratio of the Expenses (in $) of Salary of employees in 2000 to that in 2001?
Offer a very short reply. 0.94. What is the ratio of the Expenses (in $) in Custom duties in 2000 to that in 2001?
Your response must be concise. 1.13. What is the ratio of the Expenses (in $) of Interest Payments in 2000 to that in 2001?
Your answer should be compact. 0.94. What is the ratio of the Expenses (in $) of Other expenses in 2000 to that in 2001?
Your answer should be very brief. 0.89. What is the ratio of the Expenses (in $) of Salary of employees in 2000 to that in 2002?
Provide a short and direct response. 0.81. What is the ratio of the Expenses (in $) of Custom duties in 2000 to that in 2002?
Offer a very short reply. 0.98. What is the ratio of the Expenses (in $) of Interest Payments in 2000 to that in 2002?
Provide a succinct answer. 0.94. What is the ratio of the Expenses (in $) in Other expenses in 2000 to that in 2002?
Provide a succinct answer. 0.87. What is the ratio of the Expenses (in $) of Salary of employees in 2000 to that in 2003?
Your answer should be very brief. 0.75. What is the ratio of the Expenses (in $) of Custom duties in 2000 to that in 2003?
Provide a short and direct response. 0.92. What is the ratio of the Expenses (in $) in Interest Payments in 2000 to that in 2003?
Offer a very short reply. 0.86. What is the ratio of the Expenses (in $) of Other expenses in 2000 to that in 2003?
Offer a very short reply. 0.8. What is the ratio of the Expenses (in $) of Salary of employees in 2000 to that in 2004?
Keep it short and to the point. 0.69. What is the ratio of the Expenses (in $) in Custom duties in 2000 to that in 2004?
Ensure brevity in your answer.  0.93. What is the ratio of the Expenses (in $) of Interest Payments in 2000 to that in 2004?
Your answer should be very brief. 0.83. What is the ratio of the Expenses (in $) of Other expenses in 2000 to that in 2004?
Provide a succinct answer. 0.66. What is the ratio of the Expenses (in $) of Salary of employees in 2000 to that in 2005?
Make the answer very short. 0.64. What is the ratio of the Expenses (in $) of Custom duties in 2000 to that in 2005?
Your answer should be very brief. 1.06. What is the ratio of the Expenses (in $) in Interest Payments in 2000 to that in 2005?
Provide a succinct answer. 0.78. What is the ratio of the Expenses (in $) of Other expenses in 2000 to that in 2005?
Provide a succinct answer. 0.61. What is the ratio of the Expenses (in $) in Salary of employees in 2000 to that in 2006?
Provide a succinct answer. 0.57. What is the ratio of the Expenses (in $) in Custom duties in 2000 to that in 2006?
Give a very brief answer. 1.34. What is the ratio of the Expenses (in $) of Interest Payments in 2000 to that in 2006?
Ensure brevity in your answer.  0.72. What is the ratio of the Expenses (in $) in Other expenses in 2000 to that in 2006?
Make the answer very short. 0.56. What is the ratio of the Expenses (in $) in Salary of employees in 2001 to that in 2002?
Your answer should be compact. 0.86. What is the ratio of the Expenses (in $) in Custom duties in 2001 to that in 2002?
Your answer should be compact. 0.87. What is the ratio of the Expenses (in $) in Other expenses in 2001 to that in 2002?
Your answer should be compact. 0.98. What is the ratio of the Expenses (in $) in Salary of employees in 2001 to that in 2003?
Give a very brief answer. 0.8. What is the ratio of the Expenses (in $) in Custom duties in 2001 to that in 2003?
Your answer should be very brief. 0.81. What is the ratio of the Expenses (in $) of Interest Payments in 2001 to that in 2003?
Provide a succinct answer. 0.91. What is the ratio of the Expenses (in $) in Other expenses in 2001 to that in 2003?
Your answer should be very brief. 0.9. What is the ratio of the Expenses (in $) in Salary of employees in 2001 to that in 2004?
Ensure brevity in your answer.  0.73. What is the ratio of the Expenses (in $) of Custom duties in 2001 to that in 2004?
Provide a short and direct response. 0.82. What is the ratio of the Expenses (in $) in Interest Payments in 2001 to that in 2004?
Give a very brief answer. 0.88. What is the ratio of the Expenses (in $) of Other expenses in 2001 to that in 2004?
Offer a very short reply. 0.74. What is the ratio of the Expenses (in $) in Salary of employees in 2001 to that in 2005?
Provide a succinct answer. 0.68. What is the ratio of the Expenses (in $) in Custom duties in 2001 to that in 2005?
Offer a terse response. 0.94. What is the ratio of the Expenses (in $) of Interest Payments in 2001 to that in 2005?
Provide a short and direct response. 0.83. What is the ratio of the Expenses (in $) in Other expenses in 2001 to that in 2005?
Provide a short and direct response. 0.69. What is the ratio of the Expenses (in $) in Salary of employees in 2001 to that in 2006?
Your answer should be very brief. 0.61. What is the ratio of the Expenses (in $) in Custom duties in 2001 to that in 2006?
Ensure brevity in your answer.  1.19. What is the ratio of the Expenses (in $) of Interest Payments in 2001 to that in 2006?
Your answer should be compact. 0.77. What is the ratio of the Expenses (in $) in Salary of employees in 2002 to that in 2003?
Your response must be concise. 0.93. What is the ratio of the Expenses (in $) in Custom duties in 2002 to that in 2003?
Your response must be concise. 0.94. What is the ratio of the Expenses (in $) in Interest Payments in 2002 to that in 2003?
Provide a succinct answer. 0.92. What is the ratio of the Expenses (in $) in Other expenses in 2002 to that in 2003?
Ensure brevity in your answer.  0.92. What is the ratio of the Expenses (in $) in Salary of employees in 2002 to that in 2004?
Make the answer very short. 0.85. What is the ratio of the Expenses (in $) in Custom duties in 2002 to that in 2004?
Offer a terse response. 0.95. What is the ratio of the Expenses (in $) in Interest Payments in 2002 to that in 2004?
Your answer should be very brief. 0.89. What is the ratio of the Expenses (in $) in Other expenses in 2002 to that in 2004?
Offer a terse response. 0.76. What is the ratio of the Expenses (in $) in Salary of employees in 2002 to that in 2005?
Keep it short and to the point. 0.79. What is the ratio of the Expenses (in $) of Custom duties in 2002 to that in 2005?
Provide a succinct answer. 1.08. What is the ratio of the Expenses (in $) in Interest Payments in 2002 to that in 2005?
Your answer should be compact. 0.83. What is the ratio of the Expenses (in $) of Other expenses in 2002 to that in 2005?
Make the answer very short. 0.7. What is the ratio of the Expenses (in $) of Salary of employees in 2002 to that in 2006?
Your response must be concise. 0.71. What is the ratio of the Expenses (in $) in Custom duties in 2002 to that in 2006?
Provide a succinct answer. 1.37. What is the ratio of the Expenses (in $) in Interest Payments in 2002 to that in 2006?
Ensure brevity in your answer.  0.77. What is the ratio of the Expenses (in $) of Other expenses in 2002 to that in 2006?
Give a very brief answer. 0.64. What is the ratio of the Expenses (in $) in Salary of employees in 2003 to that in 2004?
Keep it short and to the point. 0.91. What is the ratio of the Expenses (in $) in Custom duties in 2003 to that in 2004?
Provide a succinct answer. 1.01. What is the ratio of the Expenses (in $) of Interest Payments in 2003 to that in 2004?
Make the answer very short. 0.97. What is the ratio of the Expenses (in $) of Other expenses in 2003 to that in 2004?
Your answer should be very brief. 0.82. What is the ratio of the Expenses (in $) of Salary of employees in 2003 to that in 2005?
Offer a very short reply. 0.85. What is the ratio of the Expenses (in $) of Custom duties in 2003 to that in 2005?
Provide a succinct answer. 1.16. What is the ratio of the Expenses (in $) of Interest Payments in 2003 to that in 2005?
Your answer should be compact. 0.91. What is the ratio of the Expenses (in $) of Other expenses in 2003 to that in 2005?
Keep it short and to the point. 0.77. What is the ratio of the Expenses (in $) in Salary of employees in 2003 to that in 2006?
Your answer should be compact. 0.76. What is the ratio of the Expenses (in $) of Custom duties in 2003 to that in 2006?
Your answer should be very brief. 1.46. What is the ratio of the Expenses (in $) of Interest Payments in 2003 to that in 2006?
Provide a short and direct response. 0.84. What is the ratio of the Expenses (in $) of Other expenses in 2003 to that in 2006?
Give a very brief answer. 0.7. What is the ratio of the Expenses (in $) of Salary of employees in 2004 to that in 2005?
Offer a very short reply. 0.93. What is the ratio of the Expenses (in $) in Custom duties in 2004 to that in 2005?
Ensure brevity in your answer.  1.14. What is the ratio of the Expenses (in $) of Interest Payments in 2004 to that in 2005?
Give a very brief answer. 0.94. What is the ratio of the Expenses (in $) in Other expenses in 2004 to that in 2005?
Ensure brevity in your answer.  0.93. What is the ratio of the Expenses (in $) in Salary of employees in 2004 to that in 2006?
Give a very brief answer. 0.83. What is the ratio of the Expenses (in $) of Custom duties in 2004 to that in 2006?
Your answer should be compact. 1.45. What is the ratio of the Expenses (in $) of Interest Payments in 2004 to that in 2006?
Your answer should be compact. 0.87. What is the ratio of the Expenses (in $) of Other expenses in 2004 to that in 2006?
Offer a very short reply. 0.85. What is the ratio of the Expenses (in $) in Salary of employees in 2005 to that in 2006?
Give a very brief answer. 0.9. What is the ratio of the Expenses (in $) in Custom duties in 2005 to that in 2006?
Provide a short and direct response. 1.26. What is the ratio of the Expenses (in $) of Interest Payments in 2005 to that in 2006?
Offer a terse response. 0.93. What is the ratio of the Expenses (in $) in Other expenses in 2005 to that in 2006?
Make the answer very short. 0.91. What is the difference between the highest and the second highest Expenses (in $) in Salary of employees?
Your answer should be very brief. 2.93e+09. What is the difference between the highest and the second highest Expenses (in $) of Custom duties?
Provide a succinct answer. 8.01e+08. What is the difference between the highest and the second highest Expenses (in $) in Interest Payments?
Your answer should be compact. 8.91e+08. What is the difference between the highest and the second highest Expenses (in $) in Other expenses?
Make the answer very short. 9.60e+09. What is the difference between the highest and the lowest Expenses (in $) of Salary of employees?
Your answer should be compact. 1.41e+1. What is the difference between the highest and the lowest Expenses (in $) in Custom duties?
Make the answer very short. 2.04e+09. What is the difference between the highest and the lowest Expenses (in $) of Interest Payments?
Make the answer very short. 4.55e+09. What is the difference between the highest and the lowest Expenses (in $) in Other expenses?
Your response must be concise. 4.99e+1. 